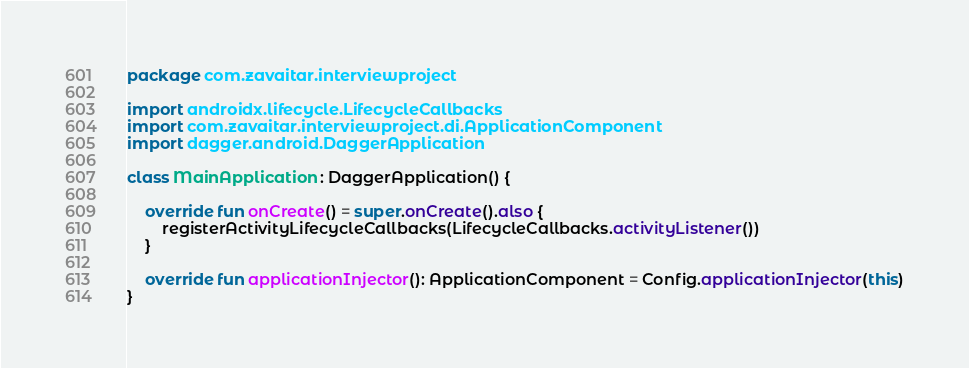Convert code to text. <code><loc_0><loc_0><loc_500><loc_500><_Kotlin_>package com.zavaitar.interviewproject

import androidx.lifecycle.LifecycleCallbacks
import com.zavaitar.interviewproject.di.ApplicationComponent
import dagger.android.DaggerApplication

class MainApplication : DaggerApplication() {

    override fun onCreate() = super.onCreate().also {
        registerActivityLifecycleCallbacks(LifecycleCallbacks.activityListener())
    }

    override fun applicationInjector(): ApplicationComponent = Config.applicationInjector(this)
}</code> 